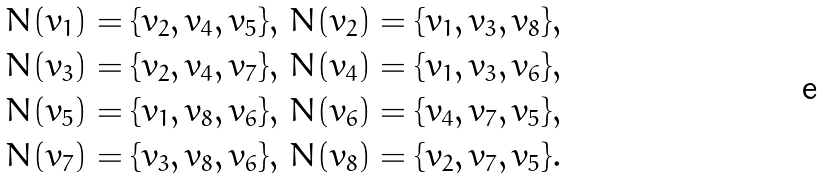<formula> <loc_0><loc_0><loc_500><loc_500>N ( v _ { 1 } ) = \{ v _ { 2 } , v _ { 4 } , v _ { 5 } \} , \, N ( v _ { 2 } ) = \{ v _ { 1 } , v _ { 3 } , v _ { 8 } \} , \\ N ( v _ { 3 } ) = \{ v _ { 2 } , v _ { 4 } , v _ { 7 } \} , \, N ( v _ { 4 } ) = \{ v _ { 1 } , v _ { 3 } , v _ { 6 } \} , \\ N ( v _ { 5 } ) = \{ v _ { 1 } , v _ { 8 } , v _ { 6 } \} , \, N ( v _ { 6 } ) = \{ v _ { 4 } , v _ { 7 } , v _ { 5 } \} , \\ N ( v _ { 7 } ) = \{ v _ { 3 } , v _ { 8 } , v _ { 6 } \} , \, N ( v _ { 8 } ) = \{ v _ { 2 } , v _ { 7 } , v _ { 5 } \} . \\</formula> 